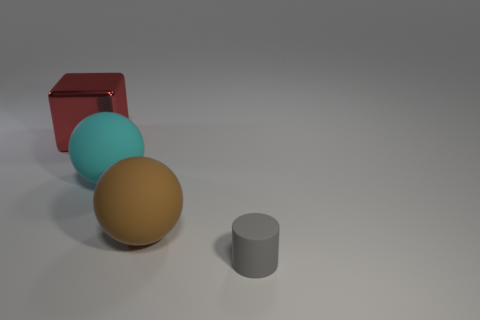What number of other objects are the same shape as the large brown matte thing?
Keep it short and to the point. 1. What size is the matte ball that is on the right side of the large cyan thing?
Provide a short and direct response. Large. There is a matte thing that is in front of the big brown matte ball; what number of gray cylinders are behind it?
Offer a very short reply. 0. What number of other things are there of the same size as the brown rubber sphere?
Offer a very short reply. 2. Is the small rubber object the same color as the big shiny cube?
Offer a terse response. No. There is a matte object left of the large brown rubber thing; is its shape the same as the big brown matte thing?
Offer a terse response. Yes. How many things are both behind the cyan thing and on the right side of the large metallic block?
Your response must be concise. 0. What is the material of the brown thing?
Ensure brevity in your answer.  Rubber. Is there any other thing of the same color as the small rubber cylinder?
Offer a terse response. No. Does the tiny gray thing have the same material as the brown thing?
Provide a short and direct response. Yes. 